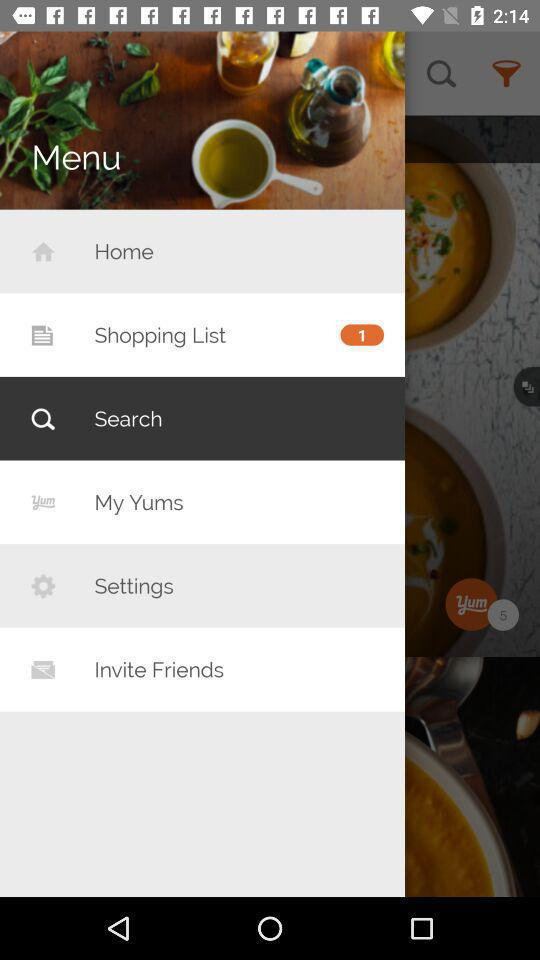What is the selected option? The selected option is "Search". 